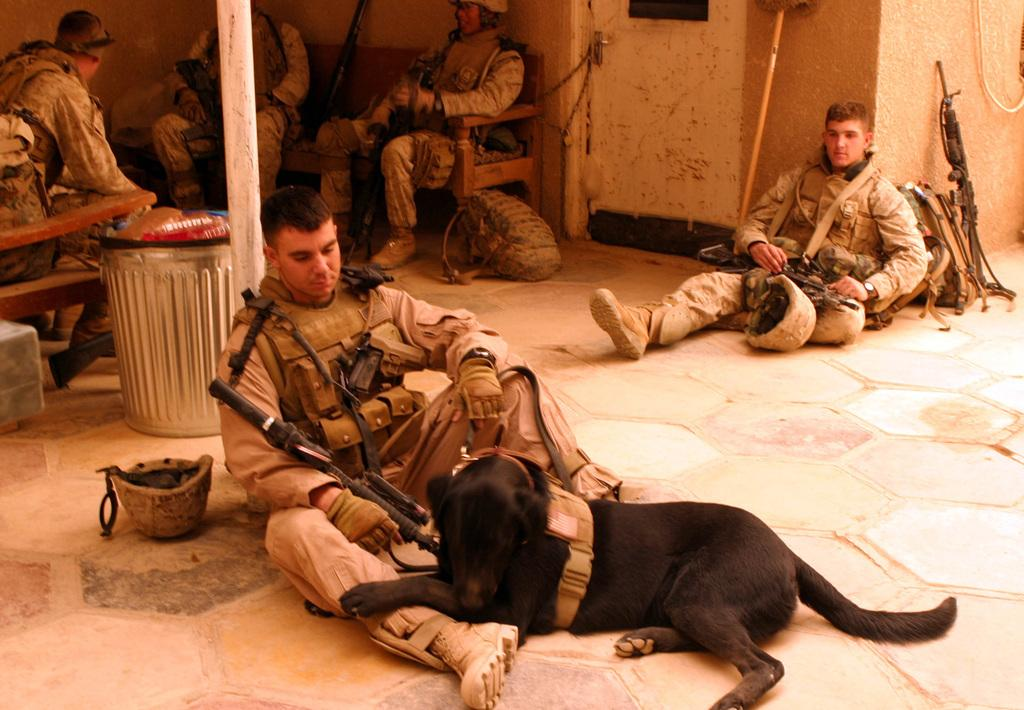How many men are present in the image? There are 5 men in the image. What are the men doing in the image? The men are sitting on the floor and sofa. What objects are near the men in the image? The men have guns near them. What type of animal is in the image? There is a dog in the image. What architectural features can be seen in the image? There is a door and a wall in the image. What type of feather can be seen on the men's clothing in the image? There are no feathers visible on the men's clothing in the image. What type of flower is on the table in the image? There is no table or flower present in the image. 